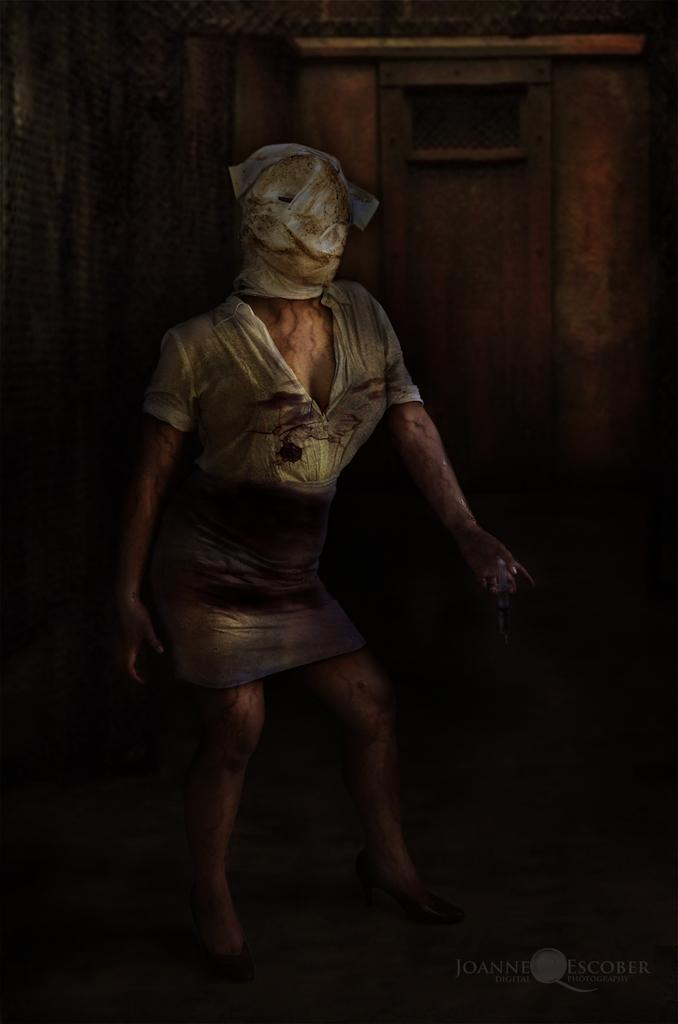What is the main subject of the image? There is a person standing in the image. What is the person doing in the image? The person is covering their face with a white cover. What can be seen in the background of the image? There is a wooden wall in the background of the image. What type of vegetable is being used as a reason for the rain in the image? There is no vegetable or rain present in the image. 